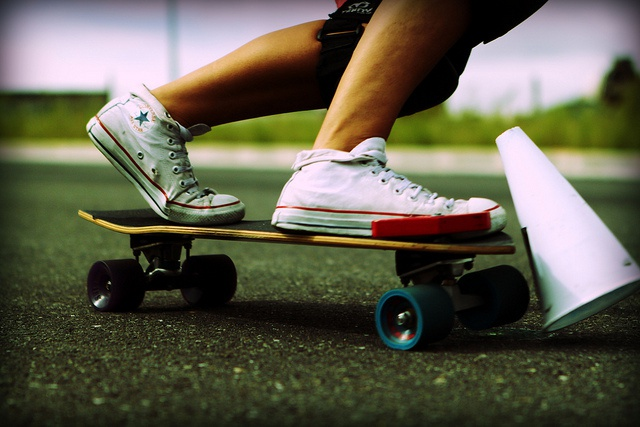Describe the objects in this image and their specific colors. I can see people in black, lavender, maroon, and olive tones and skateboard in black, darkgreen, maroon, and teal tones in this image. 